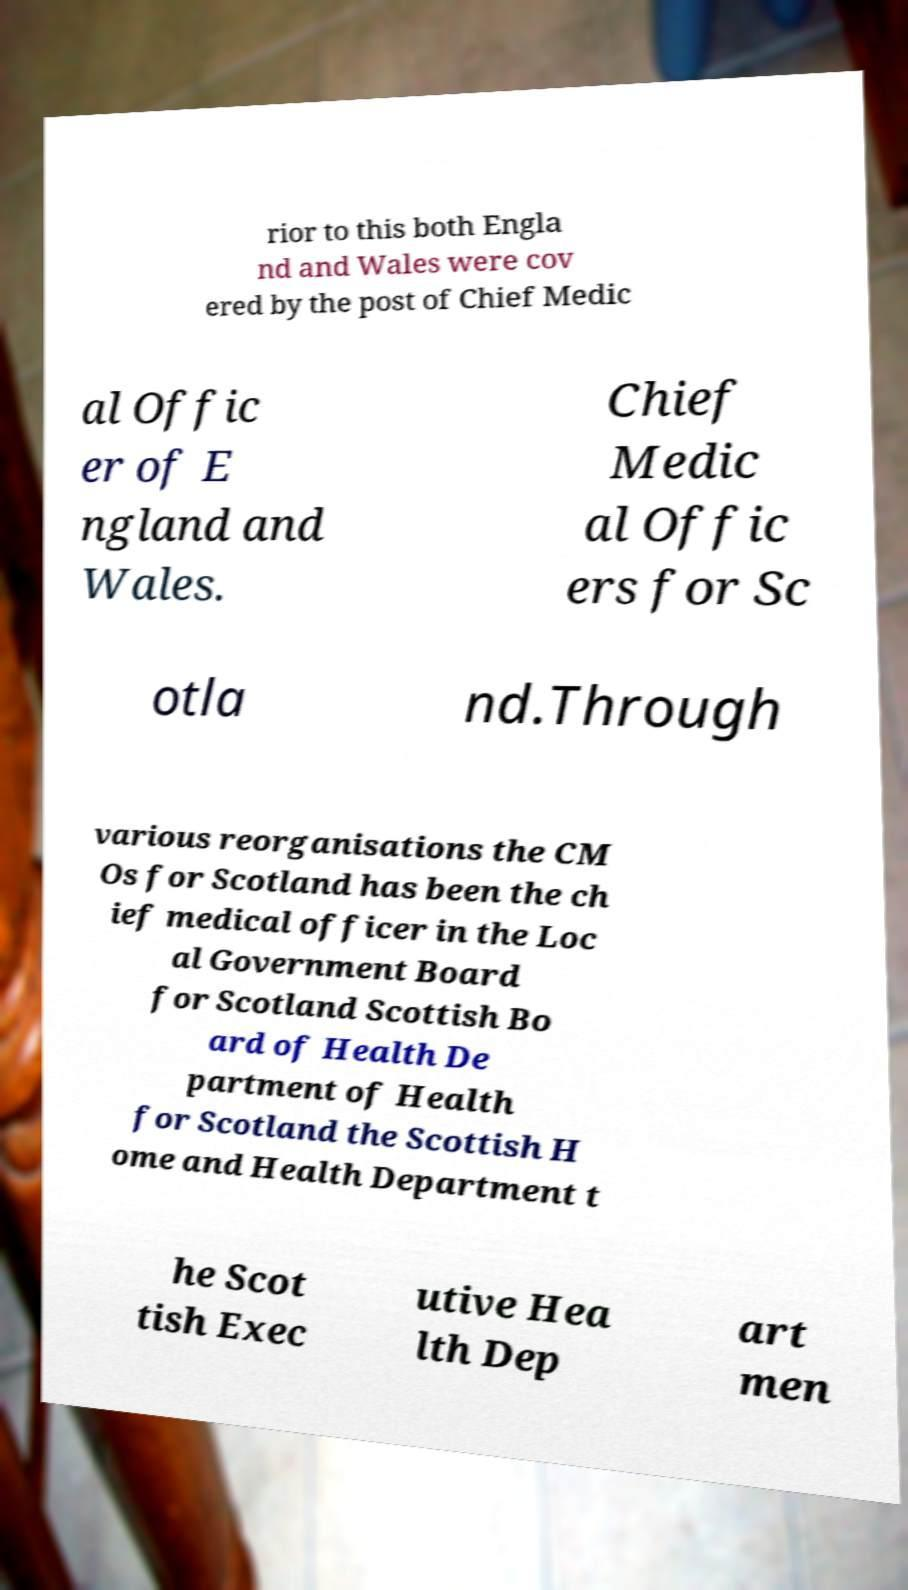I need the written content from this picture converted into text. Can you do that? rior to this both Engla nd and Wales were cov ered by the post of Chief Medic al Offic er of E ngland and Wales. Chief Medic al Offic ers for Sc otla nd.Through various reorganisations the CM Os for Scotland has been the ch ief medical officer in the Loc al Government Board for Scotland Scottish Bo ard of Health De partment of Health for Scotland the Scottish H ome and Health Department t he Scot tish Exec utive Hea lth Dep art men 